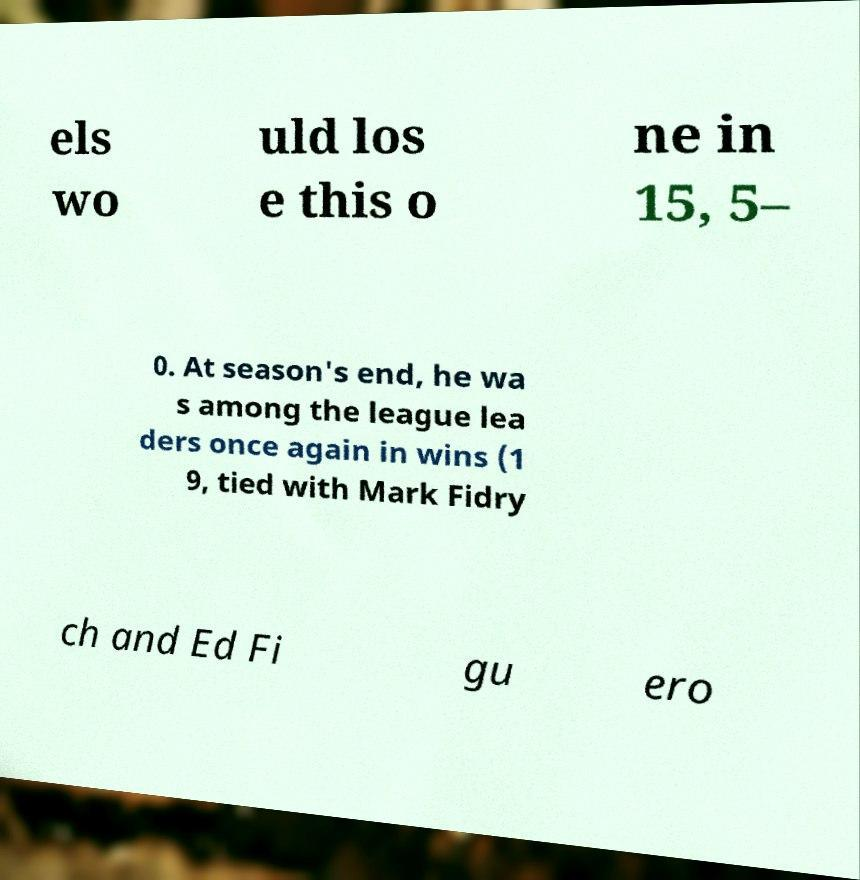I need the written content from this picture converted into text. Can you do that? els wo uld los e this o ne in 15, 5– 0. At season's end, he wa s among the league lea ders once again in wins (1 9, tied with Mark Fidry ch and Ed Fi gu ero 